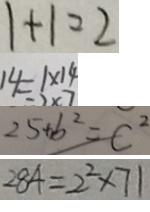Convert formula to latex. <formula><loc_0><loc_0><loc_500><loc_500>1 + 1 = 2 
 1 4 = 1 \times 1 4 
 2 5 + b ^ { 2 } = C ^ { 2 } 
 2 8 4 = 2 ^ { 2 } \times 7 1</formula> 